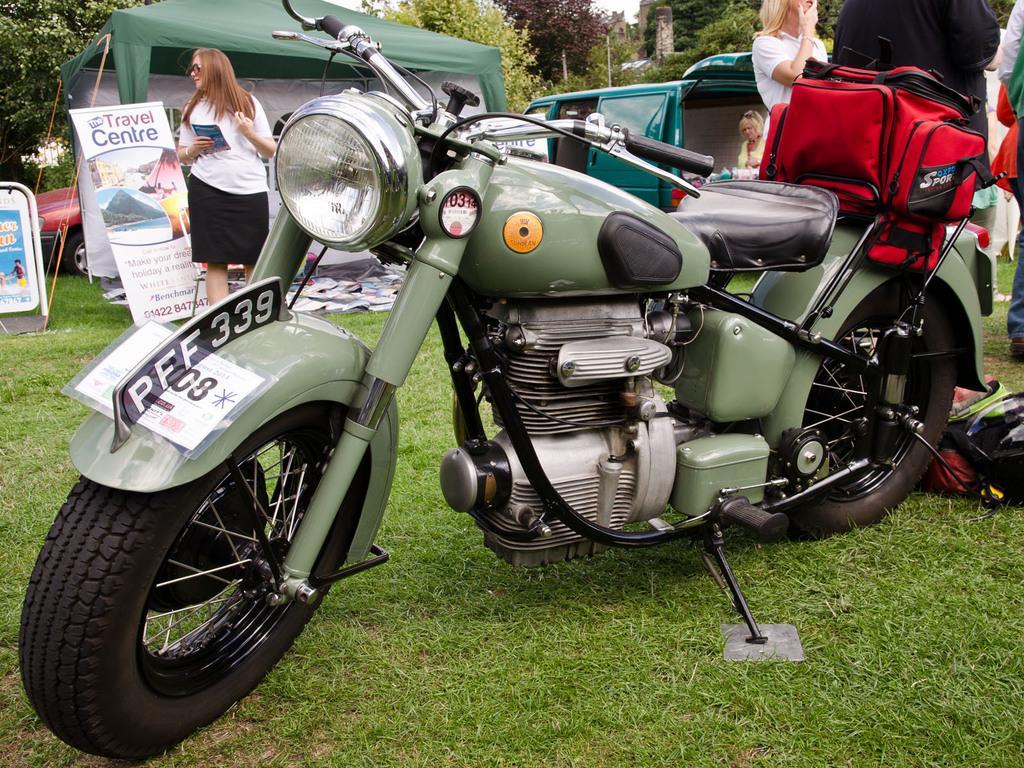Describe this image in one or two sentences. In front of the image there is a bike, on the bike there is a bag, behind the bike there are a few people standing, behind them there is a car, banners, tents. In the background of the image there are trees and poles and there are some objects on the grass surface. 